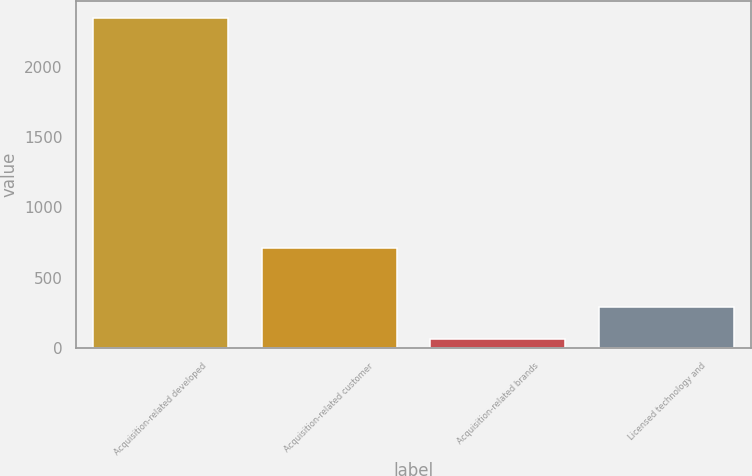Convert chart. <chart><loc_0><loc_0><loc_500><loc_500><bar_chart><fcel>Acquisition-related developed<fcel>Acquisition-related customer<fcel>Acquisition-related brands<fcel>Licensed technology and<nl><fcel>2346<fcel>713<fcel>64<fcel>292.2<nl></chart> 